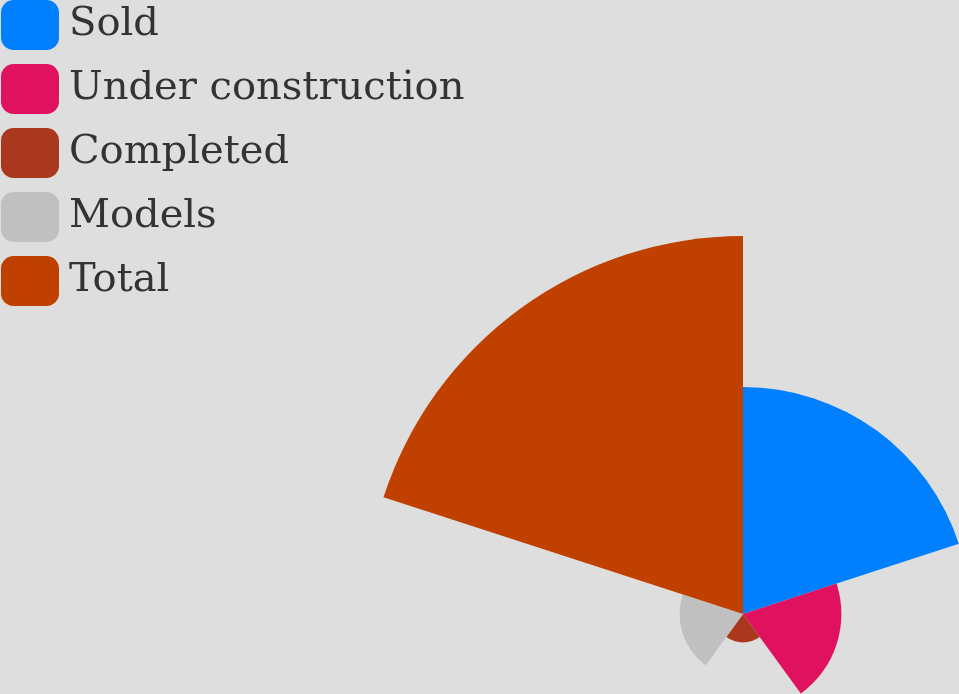Convert chart to OTSL. <chart><loc_0><loc_0><loc_500><loc_500><pie_chart><fcel>Sold<fcel>Under construction<fcel>Completed<fcel>Models<fcel>Total<nl><fcel>28.54%<fcel>12.37%<fcel>3.58%<fcel>7.98%<fcel>47.53%<nl></chart> 